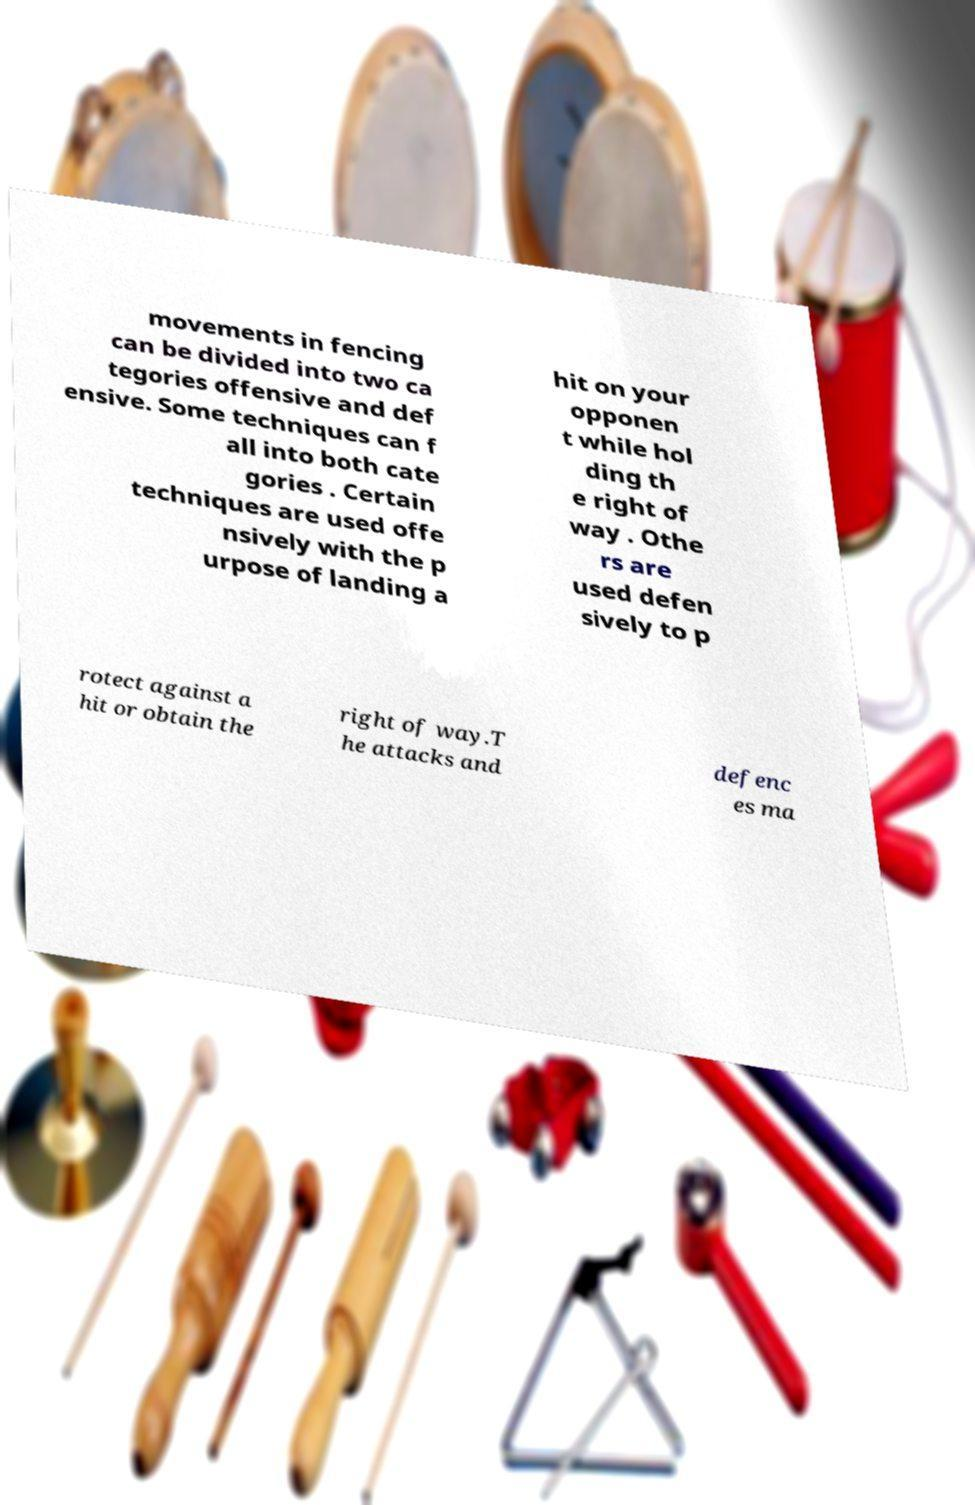What messages or text are displayed in this image? I need them in a readable, typed format. movements in fencing can be divided into two ca tegories offensive and def ensive. Some techniques can f all into both cate gories . Certain techniques are used offe nsively with the p urpose of landing a hit on your opponen t while hol ding th e right of way . Othe rs are used defen sively to p rotect against a hit or obtain the right of way.T he attacks and defenc es ma 